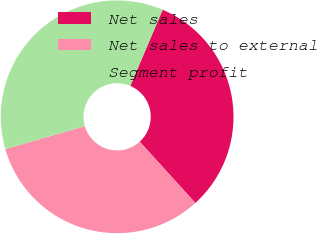Convert chart to OTSL. <chart><loc_0><loc_0><loc_500><loc_500><pie_chart><fcel>Net sales<fcel>Net sales to external<fcel>Segment profit<nl><fcel>31.87%<fcel>32.27%<fcel>35.86%<nl></chart> 